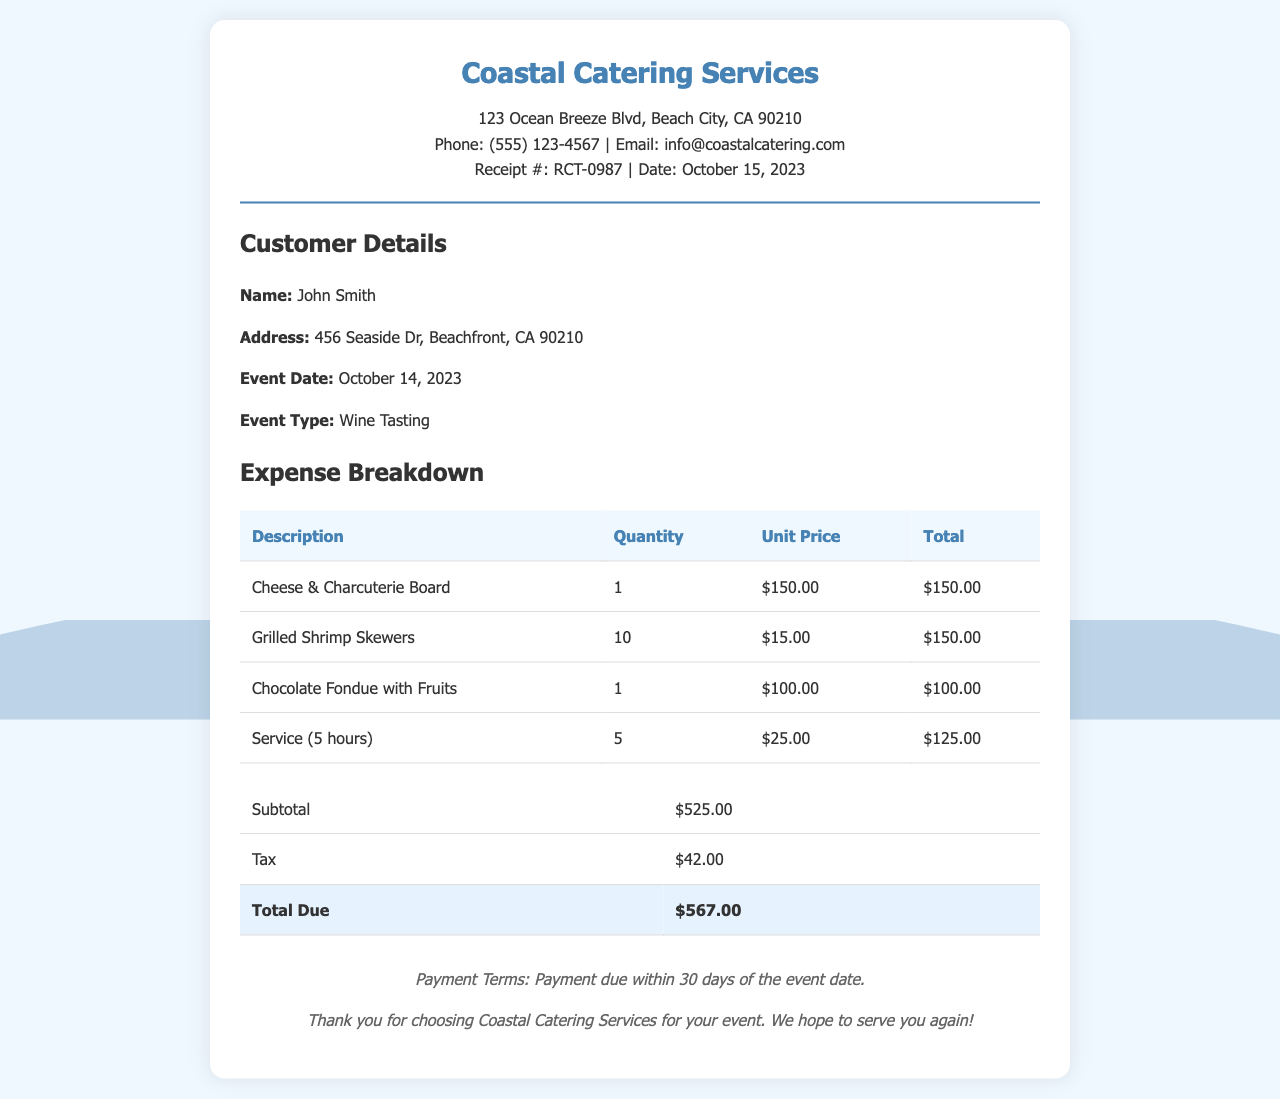What is the name of the catering service? The name of the catering service is mentioned at the top of the receipt.
Answer: Coastal Catering Services What is the receipt number? The receipt number is noted within the header section of the document.
Answer: RCT-0987 What is the total amount due? The total amount due is displayed in the totals section of the receipt.
Answer: $567.00 What food item costs $150.00? One of the food items listed has a unit price of $150.00 according to the expense breakdown.
Answer: Cheese & Charcuterie Board How many grilled shrimp skewers were ordered? The quantity of grilled shrimp skewers is provided in the expense breakdown table.
Answer: 10 What date was the event held? The date of the event is outlined in the customer details section of the receipt.
Answer: October 14, 2023 How much was charged for service hours? The cost associated with service hours can be calculated from the expense breakdown.
Answer: $125.00 What is the subtotal amount before tax? The subtotal is listed in the totals section and represents the sum of all items before tax.
Answer: $525.00 How many hours of service were provided? The hours of service are detailed in the expense breakdown section of the receipt.
Answer: 5 